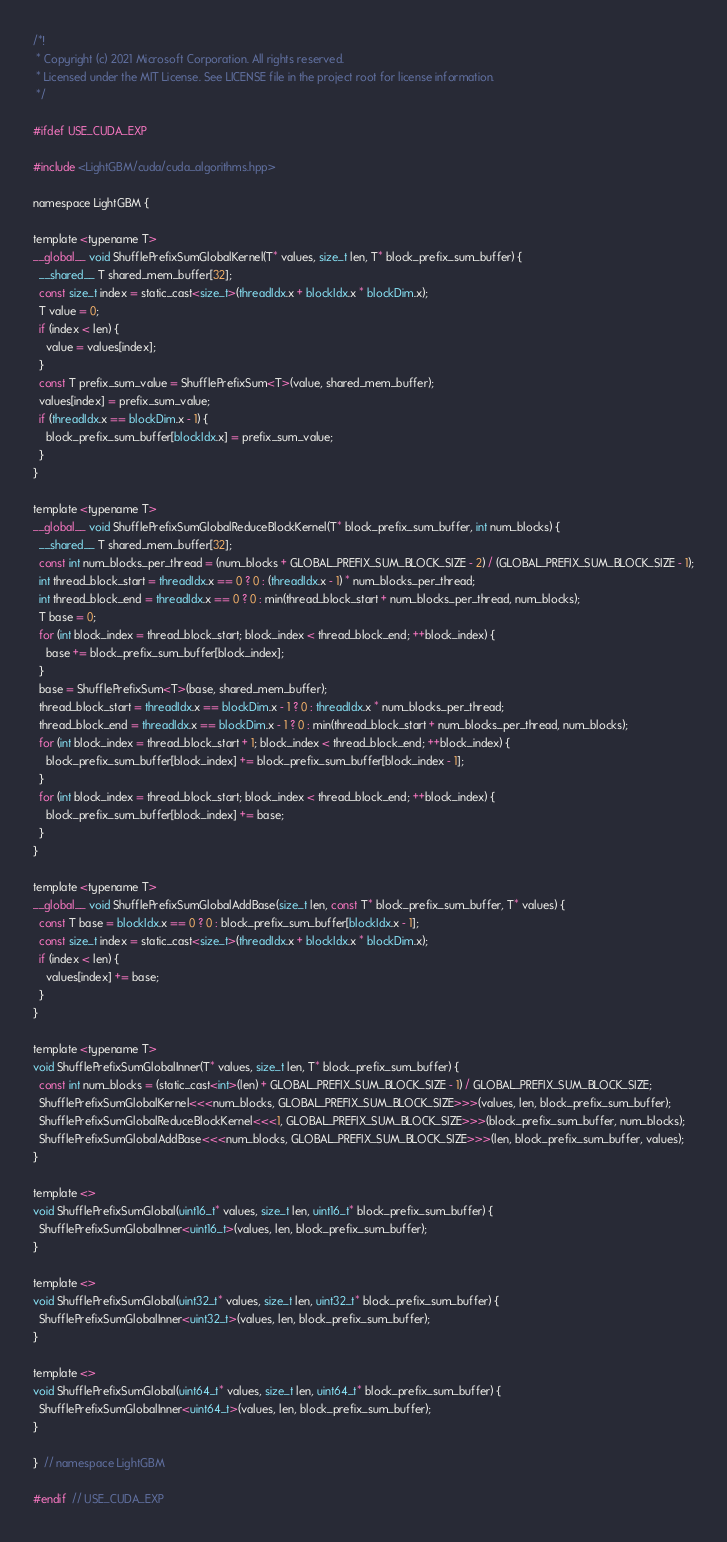Convert code to text. <code><loc_0><loc_0><loc_500><loc_500><_Cuda_>/*!
 * Copyright (c) 2021 Microsoft Corporation. All rights reserved.
 * Licensed under the MIT License. See LICENSE file in the project root for license information.
 */

#ifdef USE_CUDA_EXP

#include <LightGBM/cuda/cuda_algorithms.hpp>

namespace LightGBM {

template <typename T>
__global__ void ShufflePrefixSumGlobalKernel(T* values, size_t len, T* block_prefix_sum_buffer) {
  __shared__ T shared_mem_buffer[32];
  const size_t index = static_cast<size_t>(threadIdx.x + blockIdx.x * blockDim.x);
  T value = 0;
  if (index < len) {
    value = values[index];
  }
  const T prefix_sum_value = ShufflePrefixSum<T>(value, shared_mem_buffer);
  values[index] = prefix_sum_value;
  if (threadIdx.x == blockDim.x - 1) {
    block_prefix_sum_buffer[blockIdx.x] = prefix_sum_value;
  }
}

template <typename T>
__global__ void ShufflePrefixSumGlobalReduceBlockKernel(T* block_prefix_sum_buffer, int num_blocks) {
  __shared__ T shared_mem_buffer[32];
  const int num_blocks_per_thread = (num_blocks + GLOBAL_PREFIX_SUM_BLOCK_SIZE - 2) / (GLOBAL_PREFIX_SUM_BLOCK_SIZE - 1);
  int thread_block_start = threadIdx.x == 0 ? 0 : (threadIdx.x - 1) * num_blocks_per_thread;
  int thread_block_end = threadIdx.x == 0 ? 0 : min(thread_block_start + num_blocks_per_thread, num_blocks);
  T base = 0;
  for (int block_index = thread_block_start; block_index < thread_block_end; ++block_index) {
    base += block_prefix_sum_buffer[block_index];
  }
  base = ShufflePrefixSum<T>(base, shared_mem_buffer);
  thread_block_start = threadIdx.x == blockDim.x - 1 ? 0 : threadIdx.x * num_blocks_per_thread;
  thread_block_end = threadIdx.x == blockDim.x - 1 ? 0 : min(thread_block_start + num_blocks_per_thread, num_blocks);
  for (int block_index = thread_block_start + 1; block_index < thread_block_end; ++block_index) {
    block_prefix_sum_buffer[block_index] += block_prefix_sum_buffer[block_index - 1];
  }
  for (int block_index = thread_block_start; block_index < thread_block_end; ++block_index) {
    block_prefix_sum_buffer[block_index] += base;
  }
}

template <typename T>
__global__ void ShufflePrefixSumGlobalAddBase(size_t len, const T* block_prefix_sum_buffer, T* values) {
  const T base = blockIdx.x == 0 ? 0 : block_prefix_sum_buffer[blockIdx.x - 1];
  const size_t index = static_cast<size_t>(threadIdx.x + blockIdx.x * blockDim.x);
  if (index < len) {
    values[index] += base;
  }
}

template <typename T>
void ShufflePrefixSumGlobalInner(T* values, size_t len, T* block_prefix_sum_buffer) {
  const int num_blocks = (static_cast<int>(len) + GLOBAL_PREFIX_SUM_BLOCK_SIZE - 1) / GLOBAL_PREFIX_SUM_BLOCK_SIZE;
  ShufflePrefixSumGlobalKernel<<<num_blocks, GLOBAL_PREFIX_SUM_BLOCK_SIZE>>>(values, len, block_prefix_sum_buffer);
  ShufflePrefixSumGlobalReduceBlockKernel<<<1, GLOBAL_PREFIX_SUM_BLOCK_SIZE>>>(block_prefix_sum_buffer, num_blocks);
  ShufflePrefixSumGlobalAddBase<<<num_blocks, GLOBAL_PREFIX_SUM_BLOCK_SIZE>>>(len, block_prefix_sum_buffer, values);
}

template <>
void ShufflePrefixSumGlobal(uint16_t* values, size_t len, uint16_t* block_prefix_sum_buffer) {
  ShufflePrefixSumGlobalInner<uint16_t>(values, len, block_prefix_sum_buffer);
}

template <>
void ShufflePrefixSumGlobal(uint32_t* values, size_t len, uint32_t* block_prefix_sum_buffer) {
  ShufflePrefixSumGlobalInner<uint32_t>(values, len, block_prefix_sum_buffer);
}

template <>
void ShufflePrefixSumGlobal(uint64_t* values, size_t len, uint64_t* block_prefix_sum_buffer) {
  ShufflePrefixSumGlobalInner<uint64_t>(values, len, block_prefix_sum_buffer);
}

}  // namespace LightGBM

#endif  // USE_CUDA_EXP
</code> 